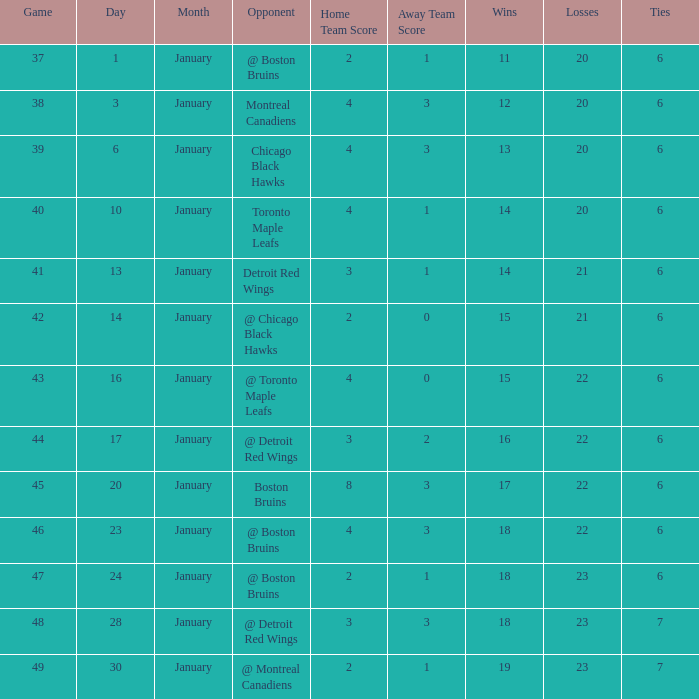What was the total number of games on January 20? 1.0. 